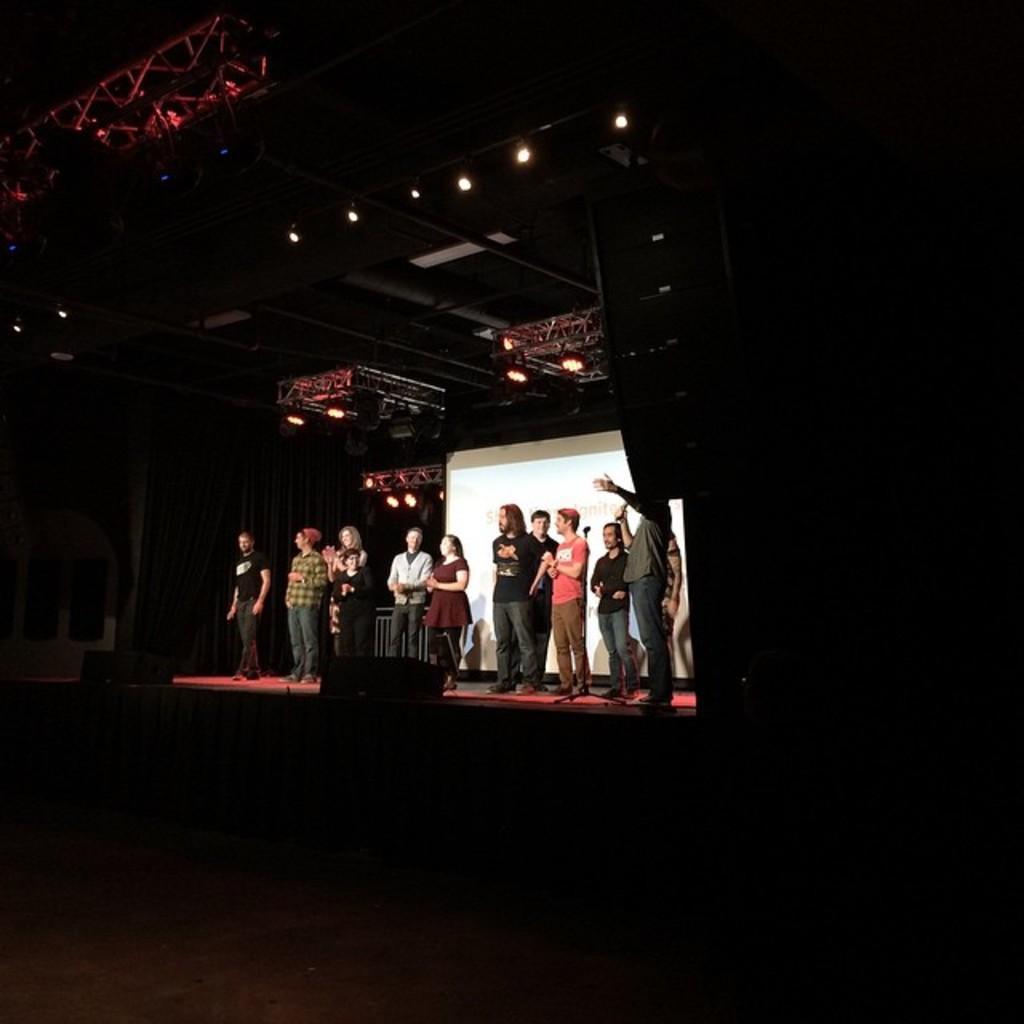Please provide a concise description of this image. There is a stage. There are many people standing on the stage. On the stage there are speakers. In the back there is curtain and a white screen. On the top there are lights. 